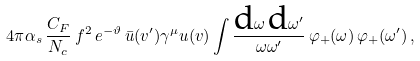Convert formula to latex. <formula><loc_0><loc_0><loc_500><loc_500>4 \pi \alpha _ { s } \, \frac { C _ { F } } { N _ { c } } \, f ^ { 2 } \, e ^ { - \vartheta } \, \bar { u } ( v ^ { \prime } ) \gamma ^ { \mu } u ( v ) \int \frac { \text {d} \omega \, \text {d} \omega ^ { \prime } } { \omega \omega ^ { \prime } } \, \varphi _ { + } ( \omega ) \, \varphi _ { + } ( \omega ^ { \prime } ) \, ,</formula> 